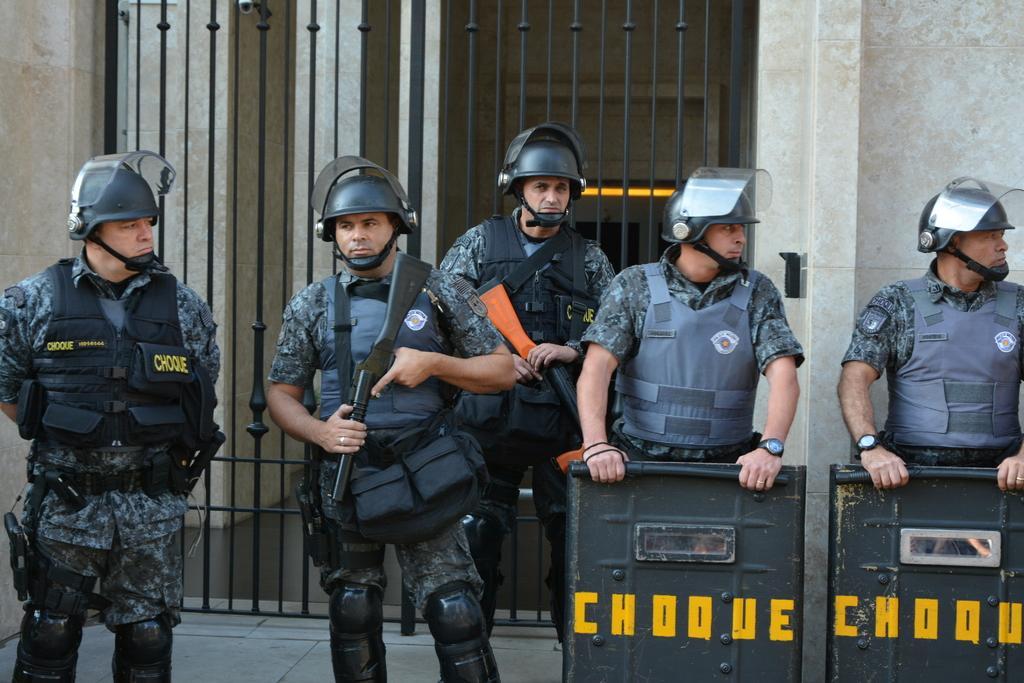Can you describe this image briefly? In this image we can see few people wearing uniforms and helmets, two of them are holding guns and two of them are holding police shields and there is a grille and wall in the background. 